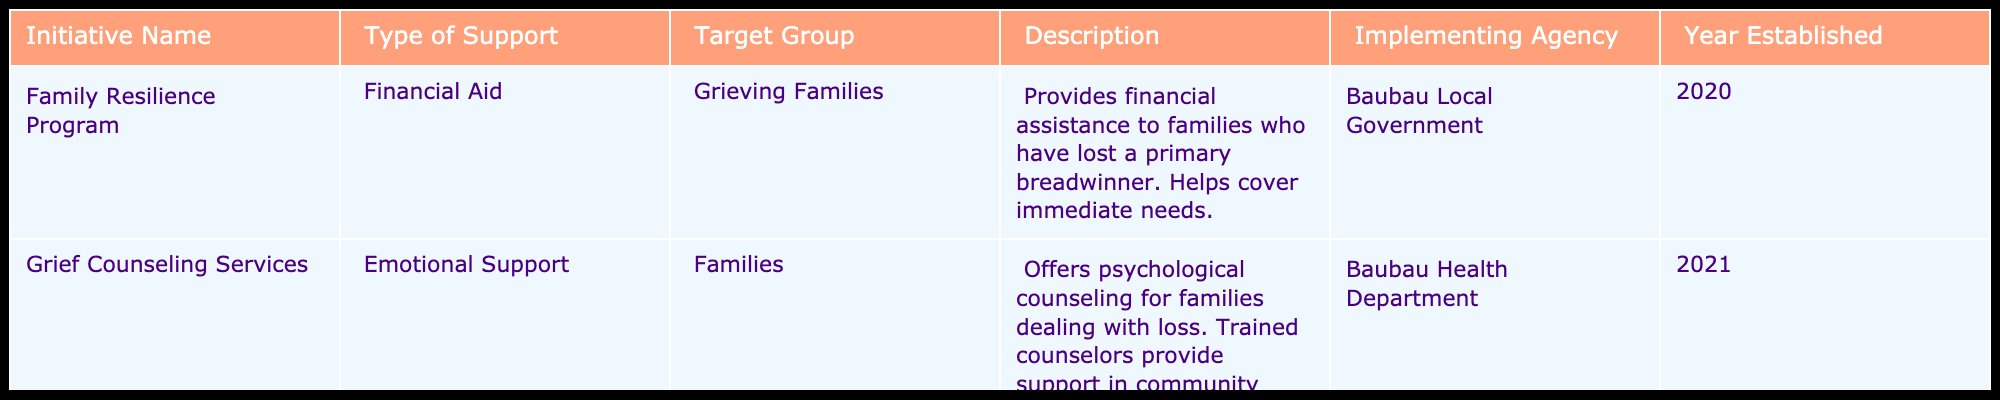What is the type of support provided by the "Family Resilience Program"? The table specifies that the "Family Resilience Program" offers Financial Aid, as indicated in the second column under "Type of Support."
Answer: Financial Aid Which implementing agency is responsible for the "Grief Counseling Services"? The table shows that the "Grief Counseling Services" are implemented by the Baubau Health Department, as mentioned in the "Implementing Agency" column.
Answer: Baubau Health Department How many initiatives were established in 2020? There is one initiative listed in the table that was established in 2020, which is the "Family Resilience Program."
Answer: 1 Are the support initiatives focused only on grieving families? The "Family Resilience Program" specifically targets grieving families, but the "Grief Counseling Services" also offers support to all families. Therefore, the support is not limited to grieving families only.
Answer: No What type of support is provided to families by the "Grief Counseling Services"? The table states that the "Grief Counseling Services" provide Emotional Support as listed under "Type of Support."
Answer: Emotional Support How many years since the establishment of the "Family Resilience Program" up to 2023? The "Family Resilience Program" was established in 2020. To find the number of years since then, we calculate 2023 - 2020 = 3 years.
Answer: 3 years Is there a program specifically for parents who have lost children? The table does not indicate any specific program solely for parents who have lost children. Both initiatives have a broader focus on grieving families or families in general.
Answer: No What is the main goal of the "Family Resilience Program"? The table describes the "Family Resilience Program" as providing financial assistance to families who have lost a primary breadwinner, covering immediate needs. Therefore, the main goal is to assist families financially in times of loss.
Answer: To assist families financially How does the type of support differ between the two initiatives? The "Family Resilience Program" provides financial aid, while the "Grief Counseling Services" offers emotional support. Hence, the type of support differs in that one is financial and the other is emotional.
Answer: Financial aid vs. emotional support 